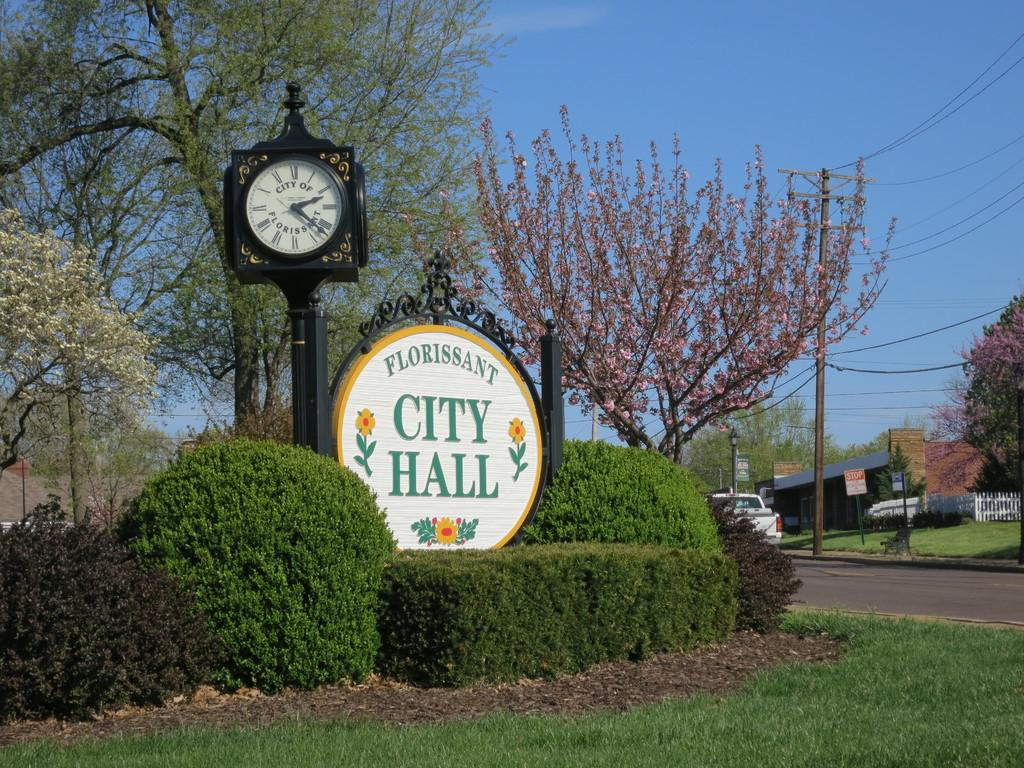<image>
Provide a brief description of the given image. A picture of a sunny day featuring a sign for Floriessant City Hall. 